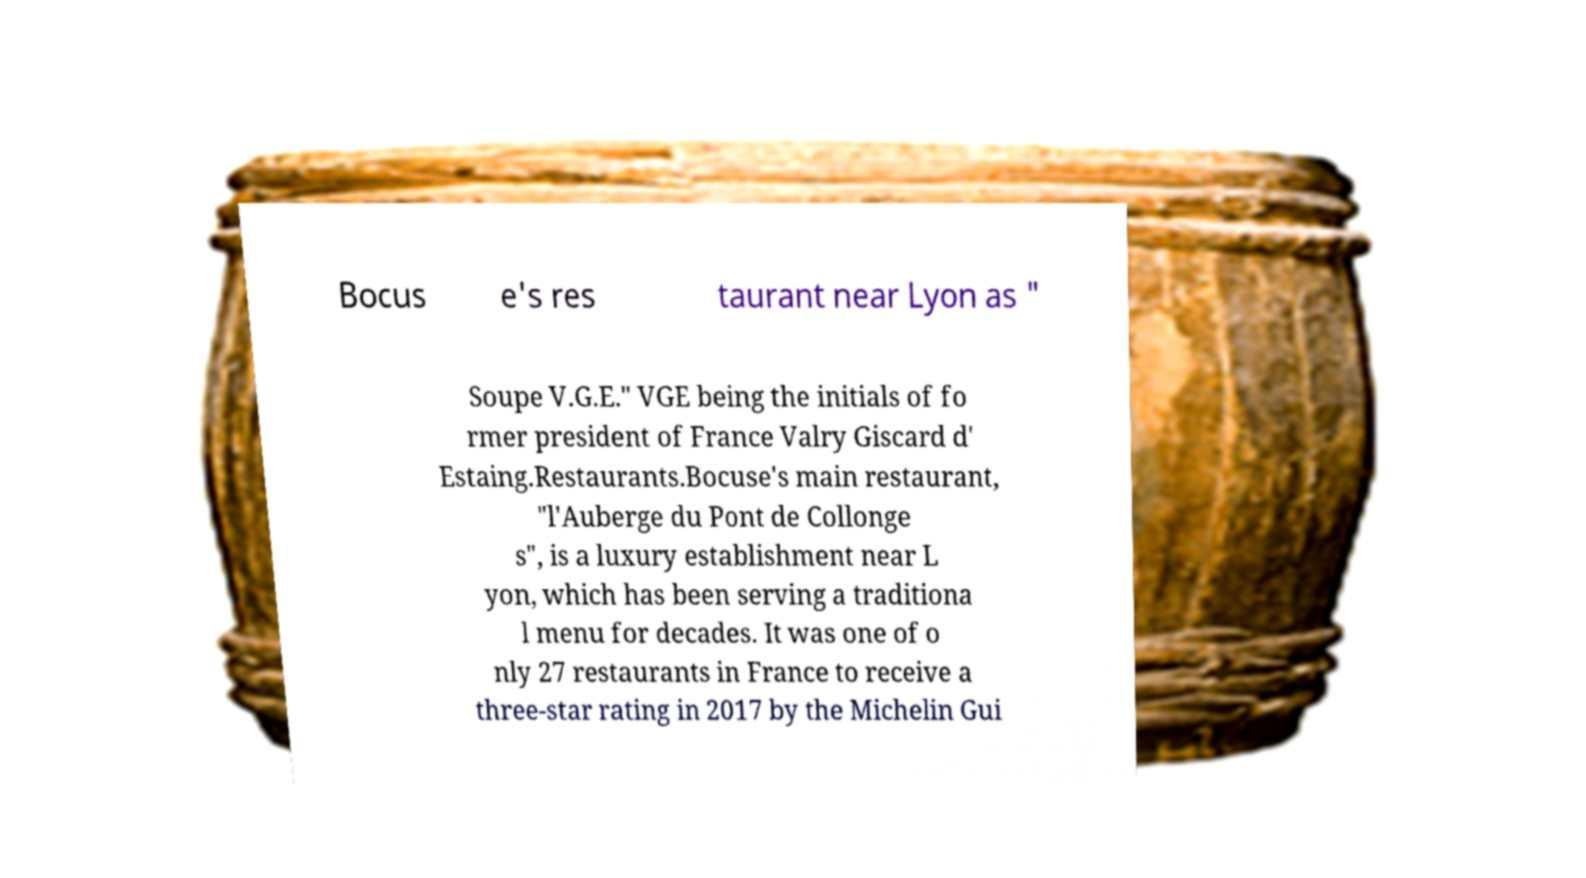Please identify and transcribe the text found in this image. Bocus e's res taurant near Lyon as " Soupe V.G.E." VGE being the initials of fo rmer president of France Valry Giscard d' Estaing.Restaurants.Bocuse's main restaurant, "l'Auberge du Pont de Collonge s", is a luxury establishment near L yon, which has been serving a traditiona l menu for decades. It was one of o nly 27 restaurants in France to receive a three-star rating in 2017 by the Michelin Gui 